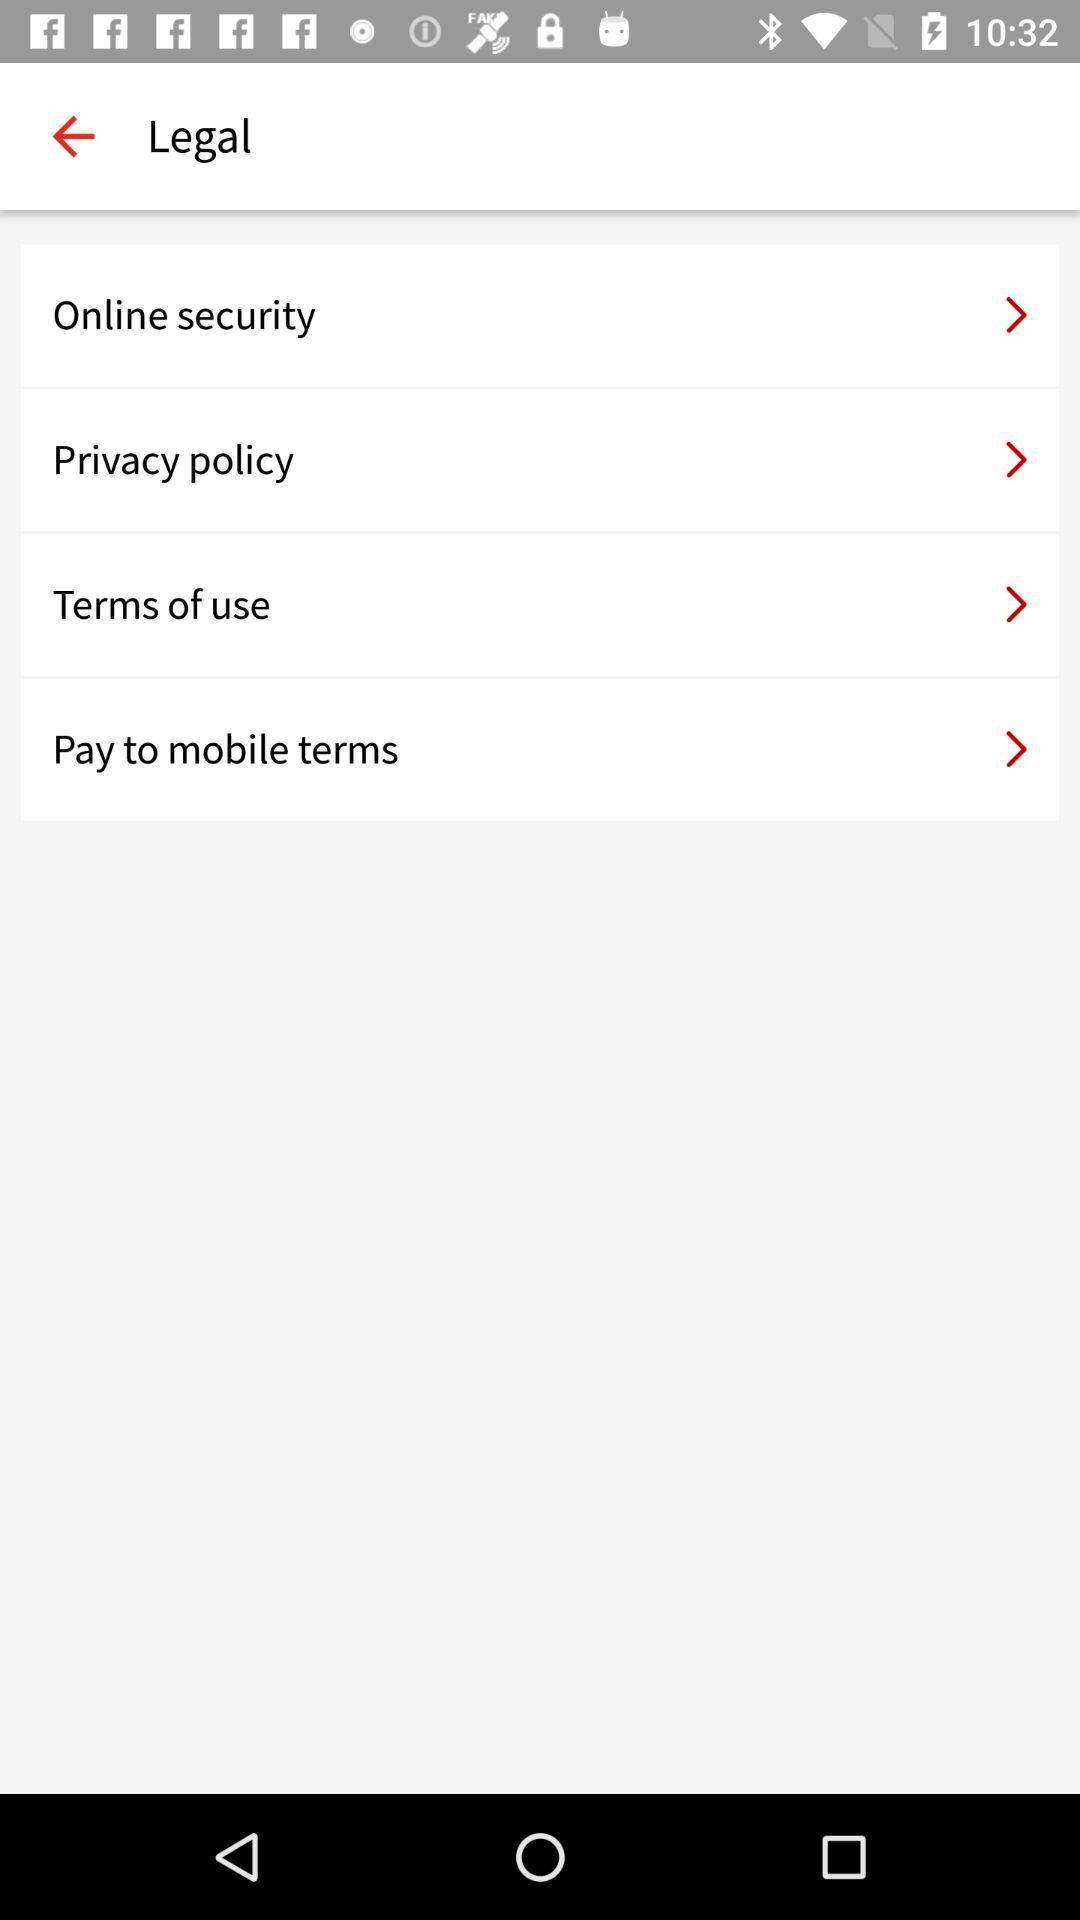Can you tell me more about the 'Pay to mobile terms' listed? Certainly! 'Pay to mobile terms' likely refer to the conditions and provisions specifically governing mobile payment services provided by the platform. This section would address the protocols for securely transferring money through mobile devices, detail any fees or limits, and lay out the dispute resolution processes for unauthorized transactions or payment issues. 